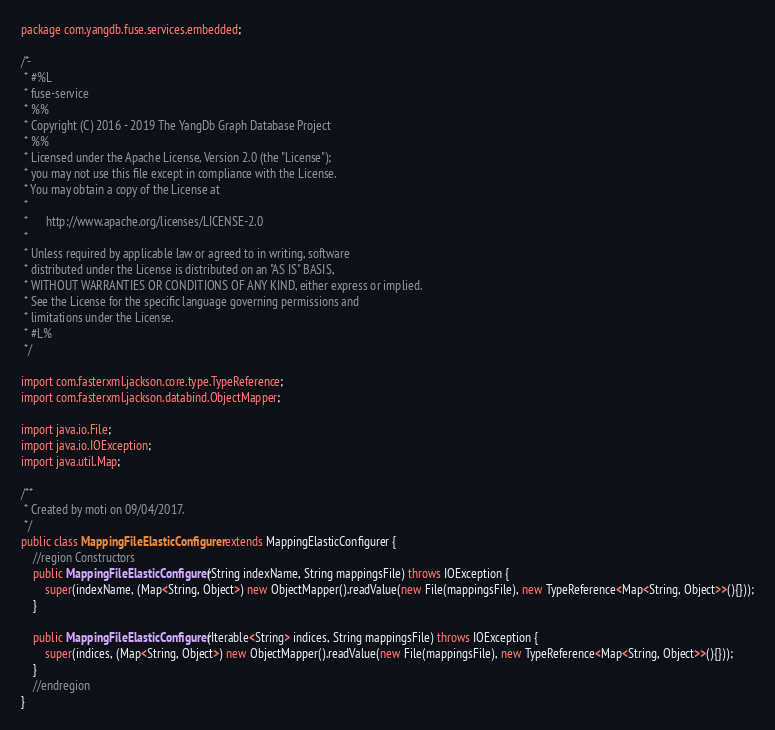Convert code to text. <code><loc_0><loc_0><loc_500><loc_500><_Java_>package com.yangdb.fuse.services.embedded;

/*-
 * #%L
 * fuse-service
 * %%
 * Copyright (C) 2016 - 2019 The YangDb Graph Database Project
 * %%
 * Licensed under the Apache License, Version 2.0 (the "License");
 * you may not use this file except in compliance with the License.
 * You may obtain a copy of the License at
 * 
 *      http://www.apache.org/licenses/LICENSE-2.0
 * 
 * Unless required by applicable law or agreed to in writing, software
 * distributed under the License is distributed on an "AS IS" BASIS,
 * WITHOUT WARRANTIES OR CONDITIONS OF ANY KIND, either express or implied.
 * See the License for the specific language governing permissions and
 * limitations under the License.
 * #L%
 */

import com.fasterxml.jackson.core.type.TypeReference;
import com.fasterxml.jackson.databind.ObjectMapper;

import java.io.File;
import java.io.IOException;
import java.util.Map;

/**
 * Created by moti on 09/04/2017.
 */
public class MappingFileElasticConfigurer extends MappingElasticConfigurer {
    //region Constructors
    public MappingFileElasticConfigurer(String indexName, String mappingsFile) throws IOException {
        super(indexName, (Map<String, Object>) new ObjectMapper().readValue(new File(mappingsFile), new TypeReference<Map<String, Object>>(){}));
    }

    public MappingFileElasticConfigurer(Iterable<String> indices, String mappingsFile) throws IOException {
        super(indices, (Map<String, Object>) new ObjectMapper().readValue(new File(mappingsFile), new TypeReference<Map<String, Object>>(){}));
    }
    //endregion
}
</code> 